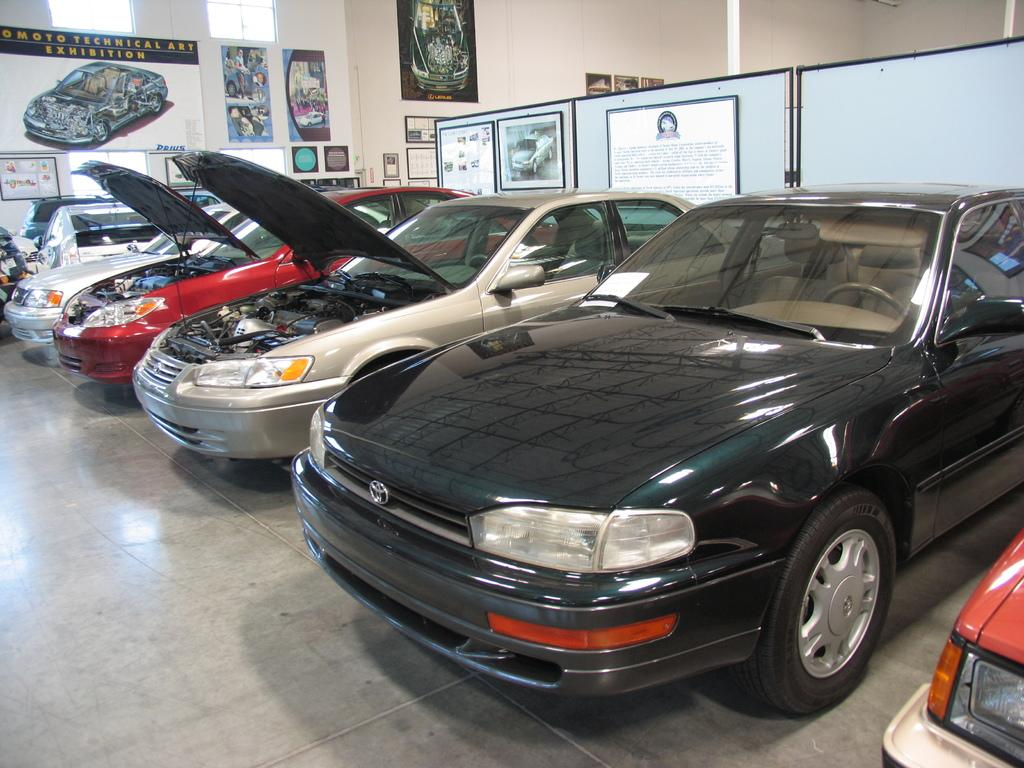What objects are on the floor in the image? There are vehicles on the floor in the image. What can be seen in the background of the image? In the background of the image, there is a wall, posters, boards, photo frames, and wall paintings. What type of space might the image have been taken in? The image may have been taken in a hall. What type of advertisement can be seen on the vehicles in the image? There is no advertisement visible on the vehicles in the image. What knowledge can be gained from the wall paintings in the image? The wall paintings in the image may convey information or tell a story, but they do not directly provide knowledge in the context of the image. 